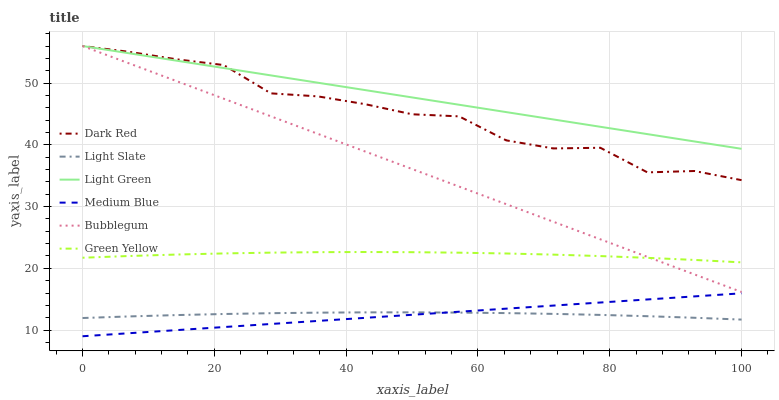Does Medium Blue have the minimum area under the curve?
Answer yes or no. Yes. Does Light Green have the maximum area under the curve?
Answer yes or no. Yes. Does Dark Red have the minimum area under the curve?
Answer yes or no. No. Does Dark Red have the maximum area under the curve?
Answer yes or no. No. Is Medium Blue the smoothest?
Answer yes or no. Yes. Is Dark Red the roughest?
Answer yes or no. Yes. Is Dark Red the smoothest?
Answer yes or no. No. Is Medium Blue the roughest?
Answer yes or no. No. Does Medium Blue have the lowest value?
Answer yes or no. Yes. Does Dark Red have the lowest value?
Answer yes or no. No. Does Light Green have the highest value?
Answer yes or no. Yes. Does Medium Blue have the highest value?
Answer yes or no. No. Is Medium Blue less than Light Green?
Answer yes or no. Yes. Is Bubblegum greater than Light Slate?
Answer yes or no. Yes. Does Light Green intersect Dark Red?
Answer yes or no. Yes. Is Light Green less than Dark Red?
Answer yes or no. No. Is Light Green greater than Dark Red?
Answer yes or no. No. Does Medium Blue intersect Light Green?
Answer yes or no. No. 